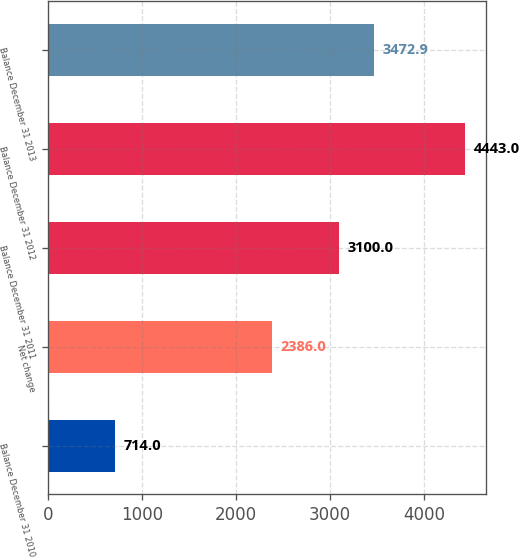<chart> <loc_0><loc_0><loc_500><loc_500><bar_chart><fcel>Balance December 31 2010<fcel>Net change<fcel>Balance December 31 2011<fcel>Balance December 31 2012<fcel>Balance December 31 2013<nl><fcel>714<fcel>2386<fcel>3100<fcel>4443<fcel>3472.9<nl></chart> 